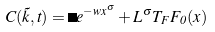Convert formula to latex. <formula><loc_0><loc_0><loc_500><loc_500>C ( \vec { k } , t ) = \Delta e ^ { - w x ^ { \sigma } } + L ^ { \sigma } T _ { F } F _ { 0 } ( x )</formula> 